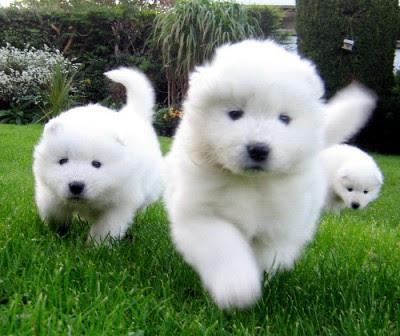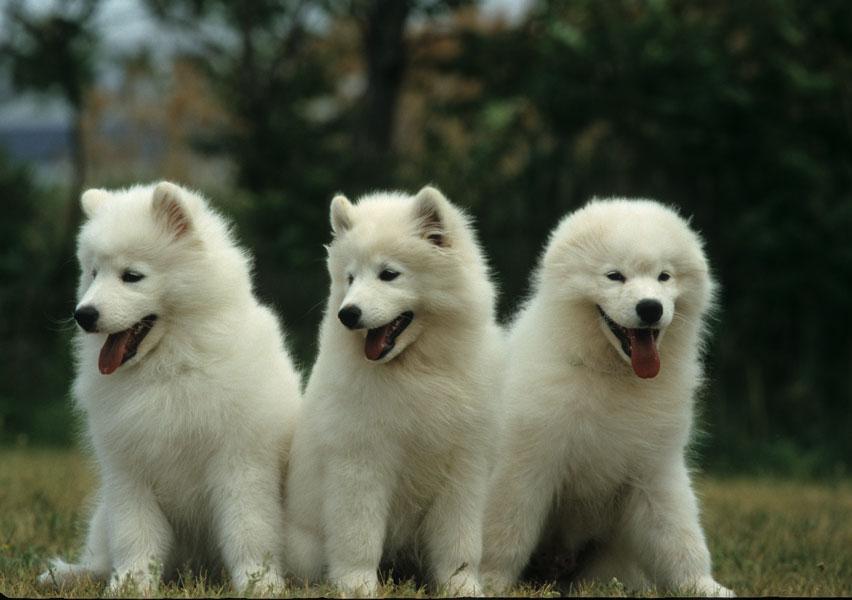The first image is the image on the left, the second image is the image on the right. For the images displayed, is the sentence "There is at least one dog facing the camera in the image on the left" factually correct? Answer yes or no. Yes. The first image is the image on the left, the second image is the image on the right. For the images displayed, is the sentence "An image shows just one fluffy dog standing on grass." factually correct? Answer yes or no. No. 